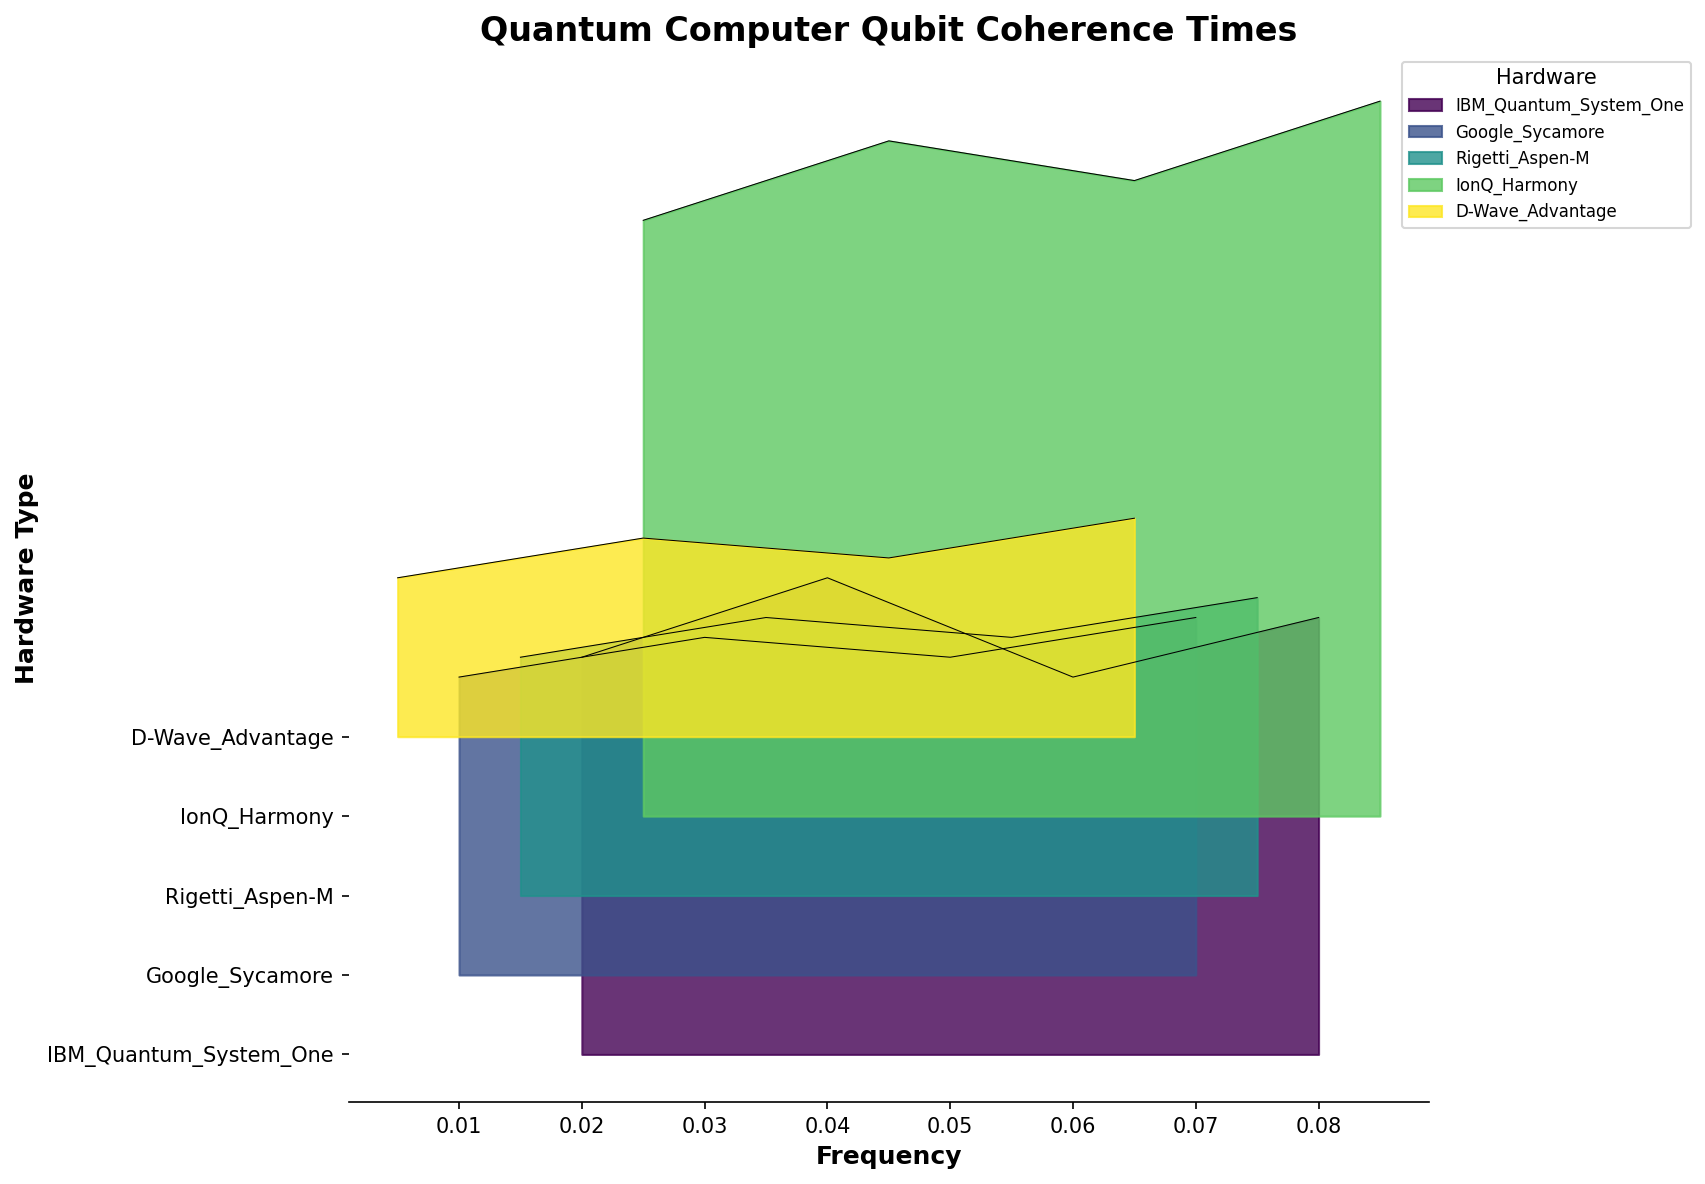What's the title of the figure? The title of the figure is usually found at the top and it provides an overview of what the plot is about. On this plot, the title given is directly visible.
Answer: Quantum Computer Qubit Coherence Times Which axis represents the different hardware types? The axis labeling on the left side of the plot indicates hardware types. This is the y-axis in this figure.
Answer: y-axis What is the coherence time of IonQ Harmony at the highest frequency? Locate the line and fill for IonQ Harmony, then find the coherence time at the maximum frequency value on the x-axis.
Answer: 180 Compare the maximum coherence times between IonQ Harmony and D-Wave Advantage. Which one is higher and by how much? IonQ Harmony's maximum coherence time is 180, and D-Wave Advantage's maximum is 55. Subtract D-Wave Advantage's maximum from IonQ Harmony's maximum.
Answer: IonQ Harmony is higher by 125 Which hardware has the lowest maximum coherence time among the ones plotted? By checking the peak coherence times for each hardware, observe that D-Wave Advantage has the lowest maximum value at 55.
Answer: D-Wave Advantage For IBM Quantum System One's coherence times, what is the shape of the data distribution as seen on the plot? Observing the filled area for IBM Quantum System One, the data distribution shape gives an indication of how coherence times spread across the frequencies. This is typical for a ridgeline plot where hills or peaks display distributions.
Answer: Multiple peaks What hardware has the broadest range of coherence times observed on the plot? By examining the spread of coherence times along the corresponding y-axis line for each hardware type, IonQ Harmony appears to span the widest range.
Answer: IonQ Harmony What is the rough midpoint of the coherence time range for Google Sycamore? Google Sycamore's coherence times range from 75 to 90. Find the midpoint by calculating (75 + 90) / 2.
Answer: 82.5 At frequency 0.045, which hardware has the highest coherence time? Find the data points at 0.045 frequency and compare the coherence times for each hardware. IonQ Harmony has the highest coherence at this frequency.
Answer: IonQ Harmony 